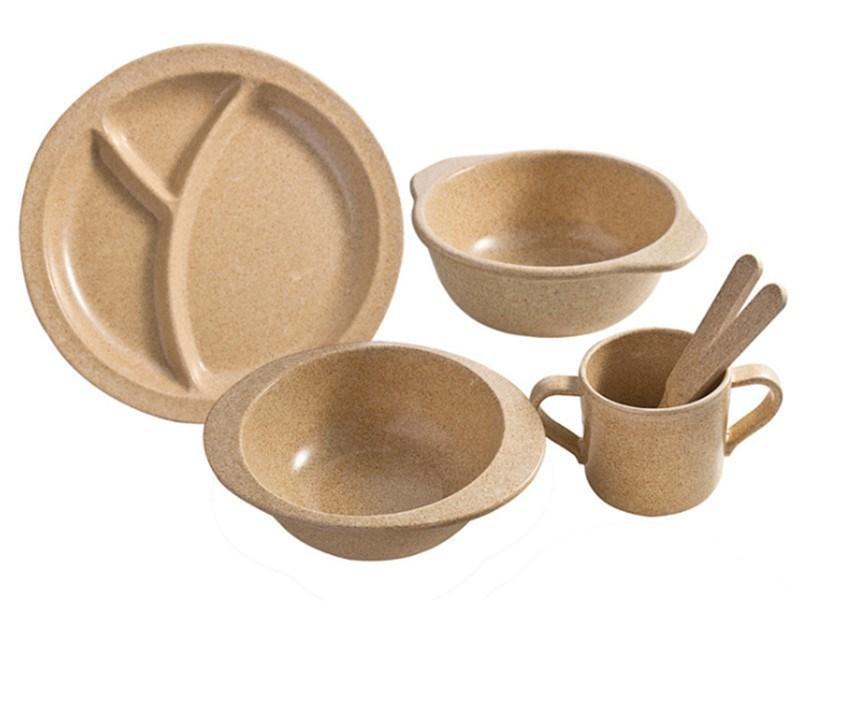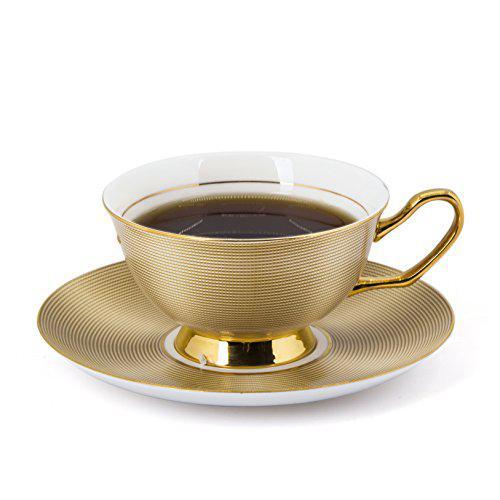The first image is the image on the left, the second image is the image on the right. Analyze the images presented: Is the assertion "An image shows beige dishware that look like melamine plastic." valid? Answer yes or no. Yes. 